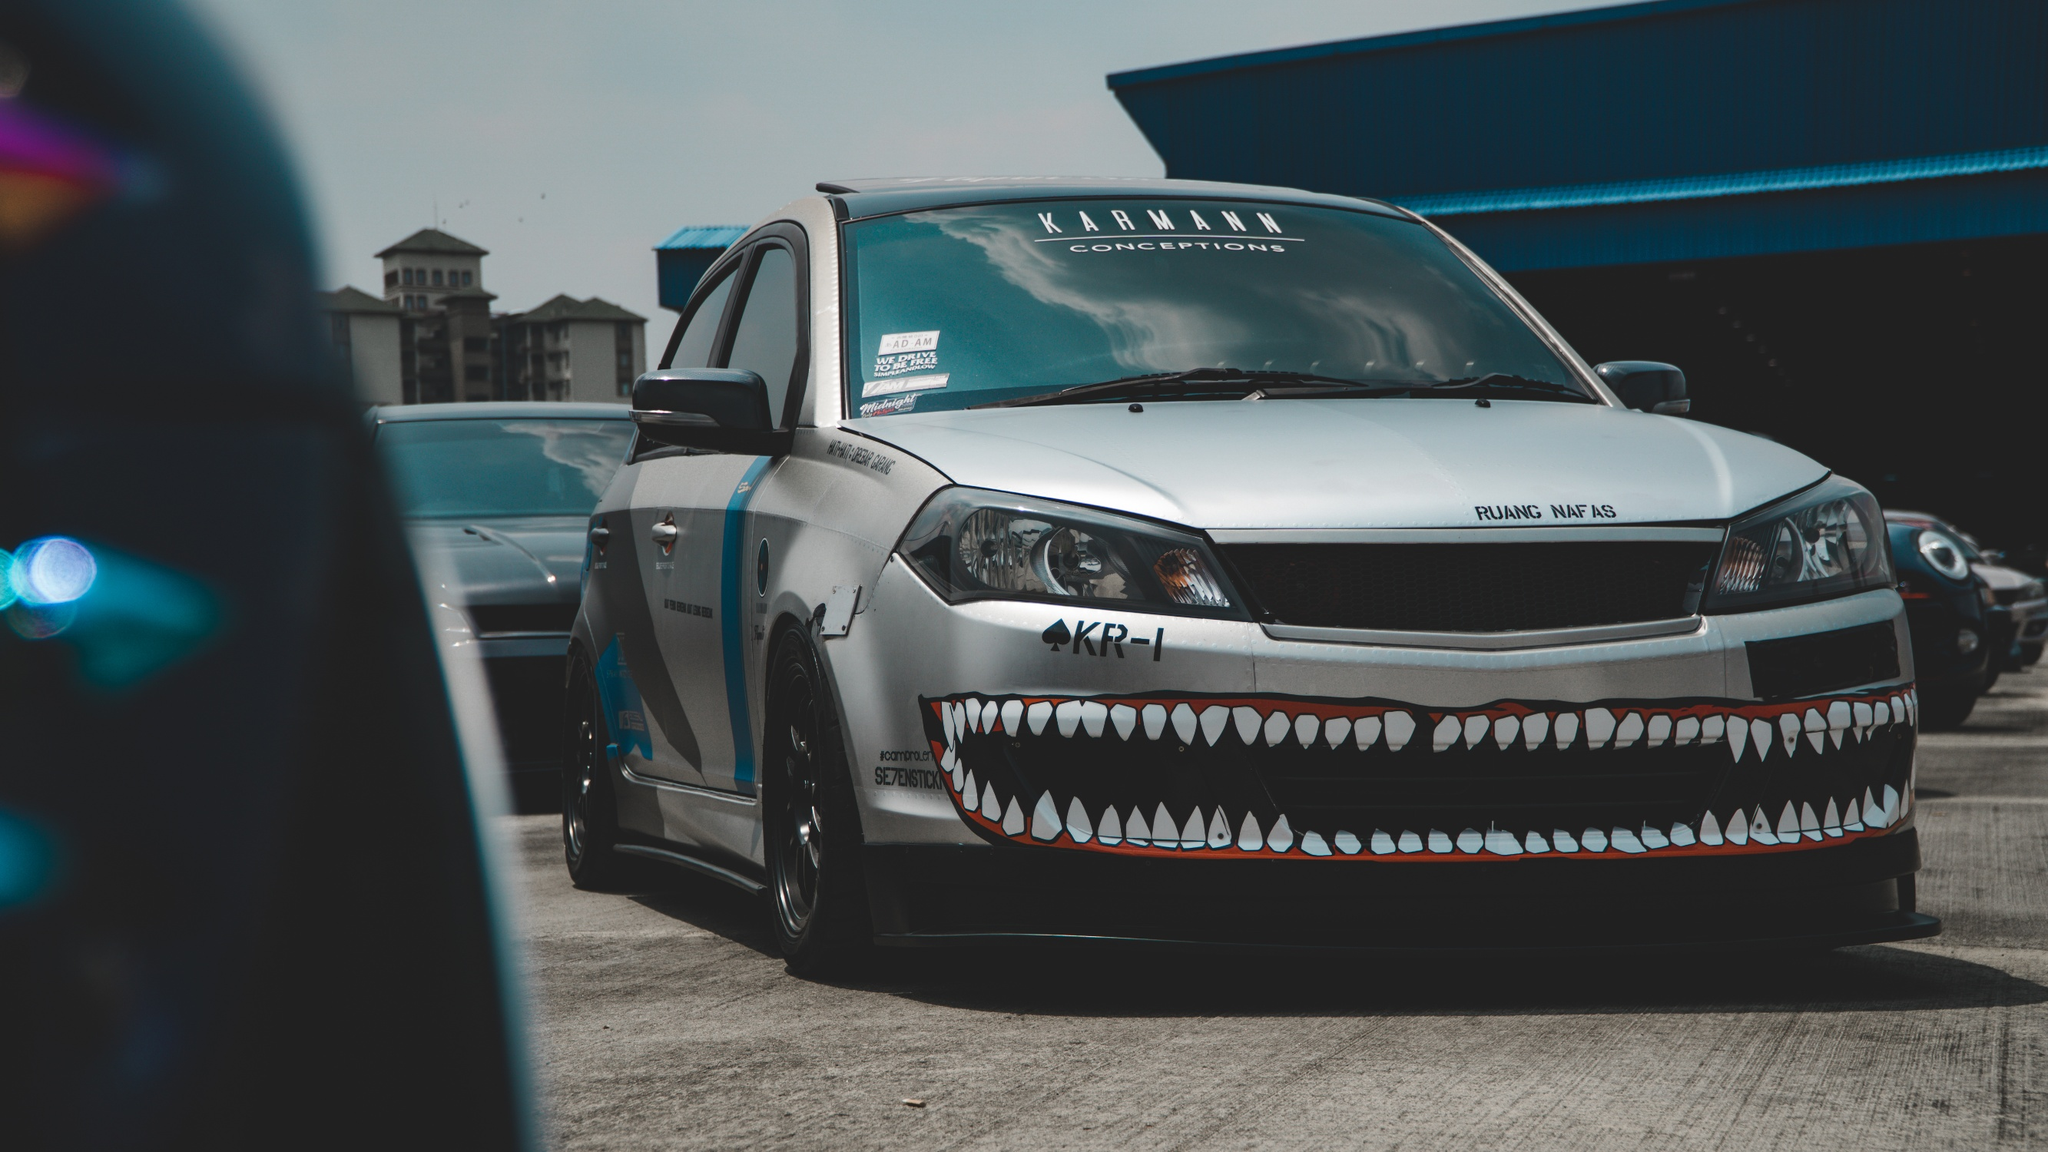Imagine that this car is a character in a movie. What type of character would it be, and what role would it play? In a movie, this car would undoubtedly be a rebellious and formidable character, often taking the role of the protagonist's trusty sidekick or even the hero itself. Known as 'The Beast', this car would be equipped with more than just speed—it would possess a personality marked by fierce determination and an unyielding spirit. 'The Beast' would roar into action scenes with its growling engine, helping the hero escape sticky situations, chase down villains, and perform high-speed stunts. Its signature shark-teeth bumper would symbolize its fierce, no-nonsense attitude, and the car's bond with the hero would be unbreakable, forged through numerous perilous escapades. Whether smashing through barriers, dodging bullets, or outmaneuvering enemy vehicles, 'The Beast' would be an icon of resilience and strength, always ready to leap into the fray and protect its allies. 